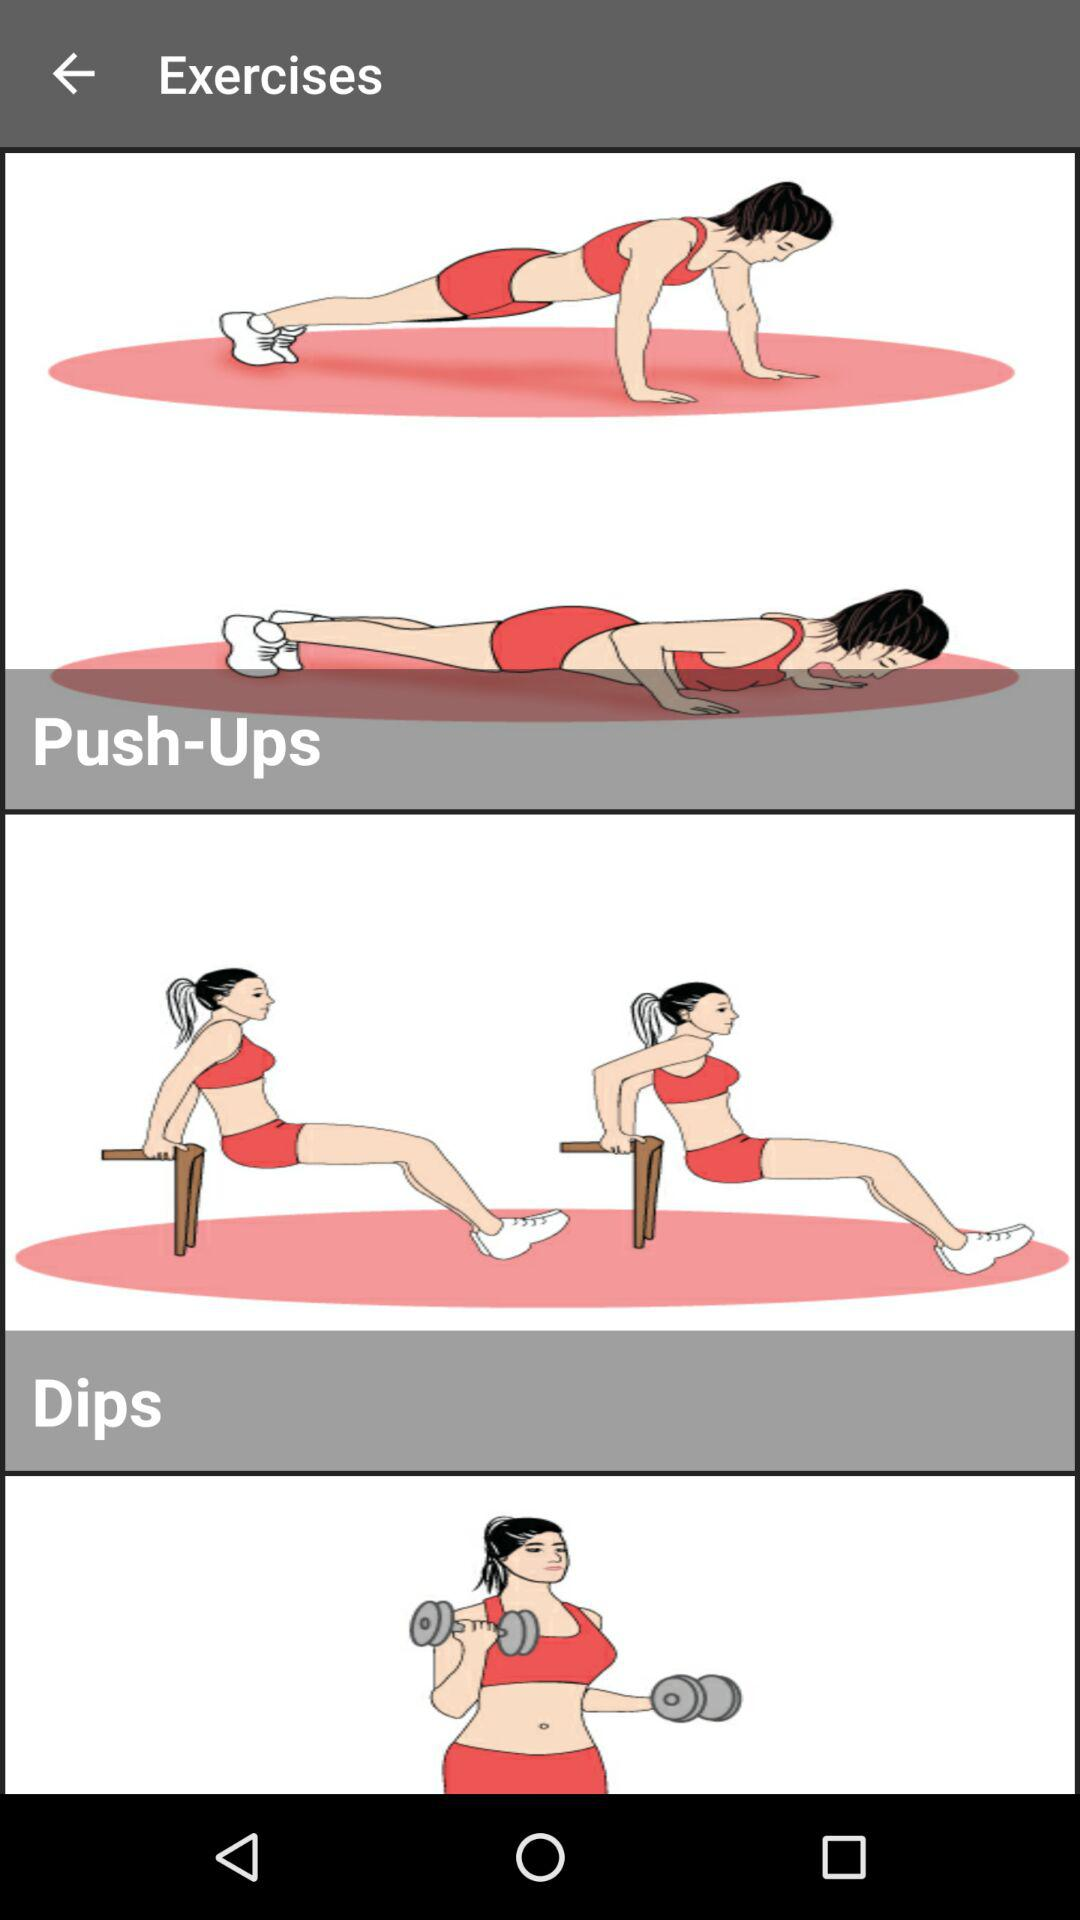How many exercises are shown on the screen?
Answer the question using a single word or phrase. 3 